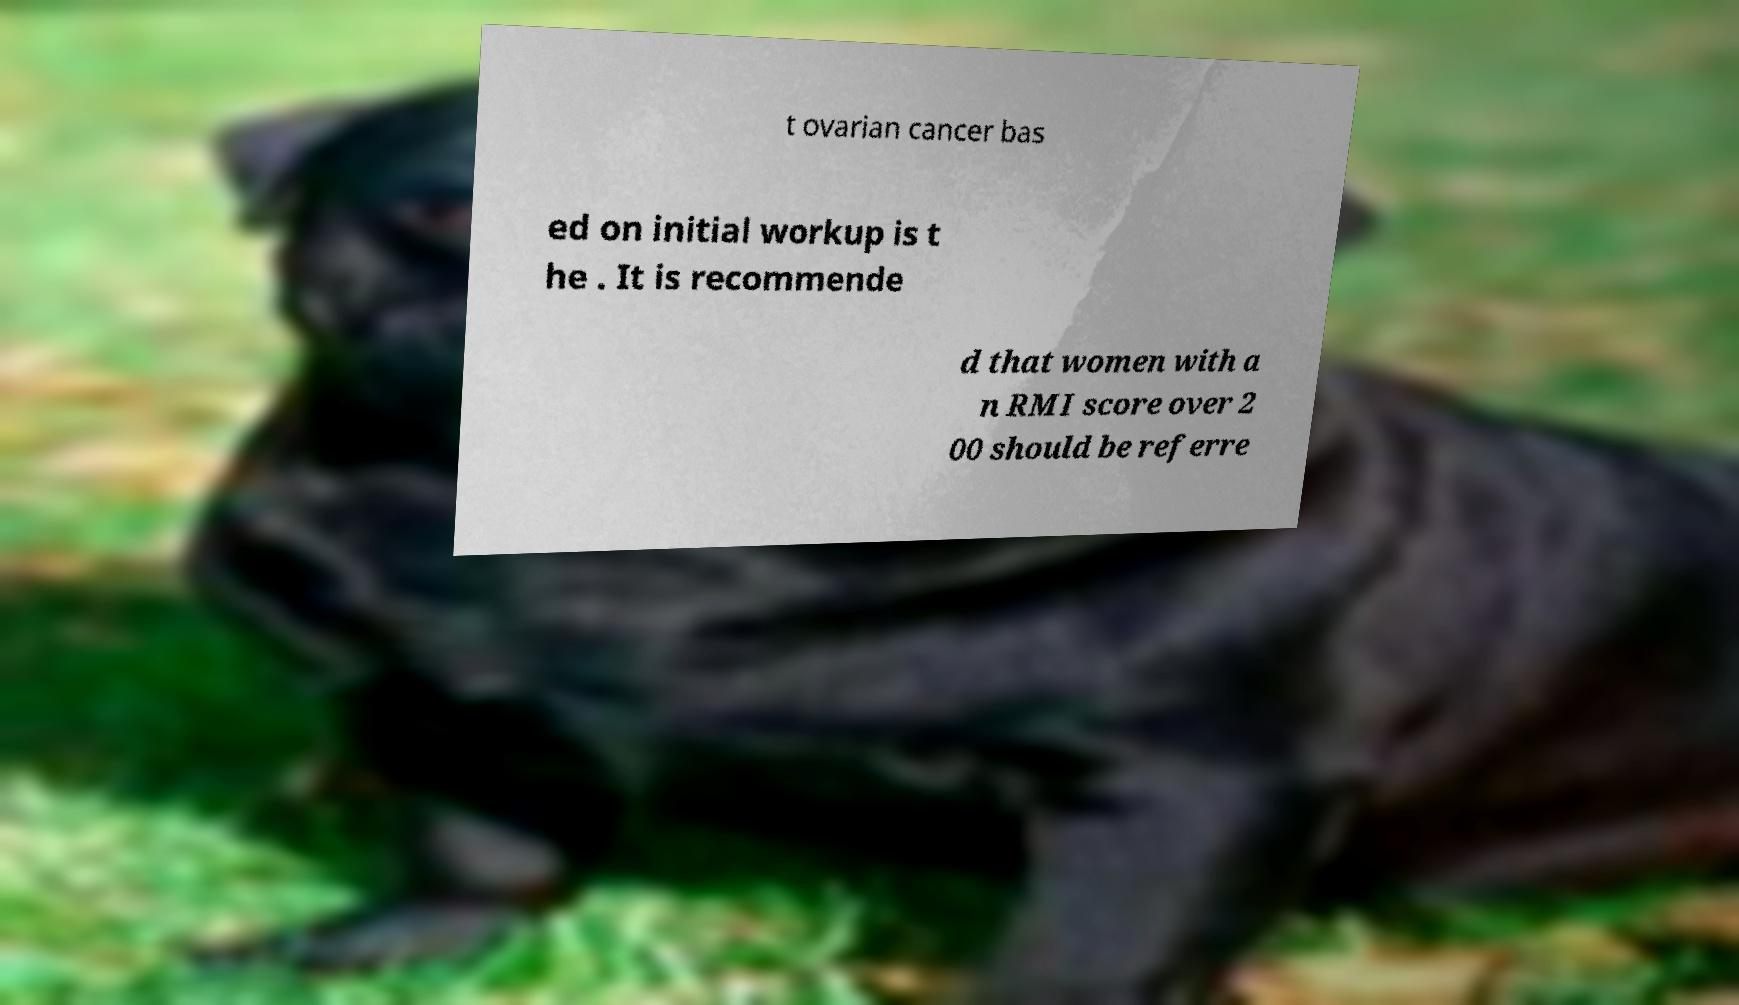Can you read and provide the text displayed in the image?This photo seems to have some interesting text. Can you extract and type it out for me? t ovarian cancer bas ed on initial workup is t he . It is recommende d that women with a n RMI score over 2 00 should be referre 